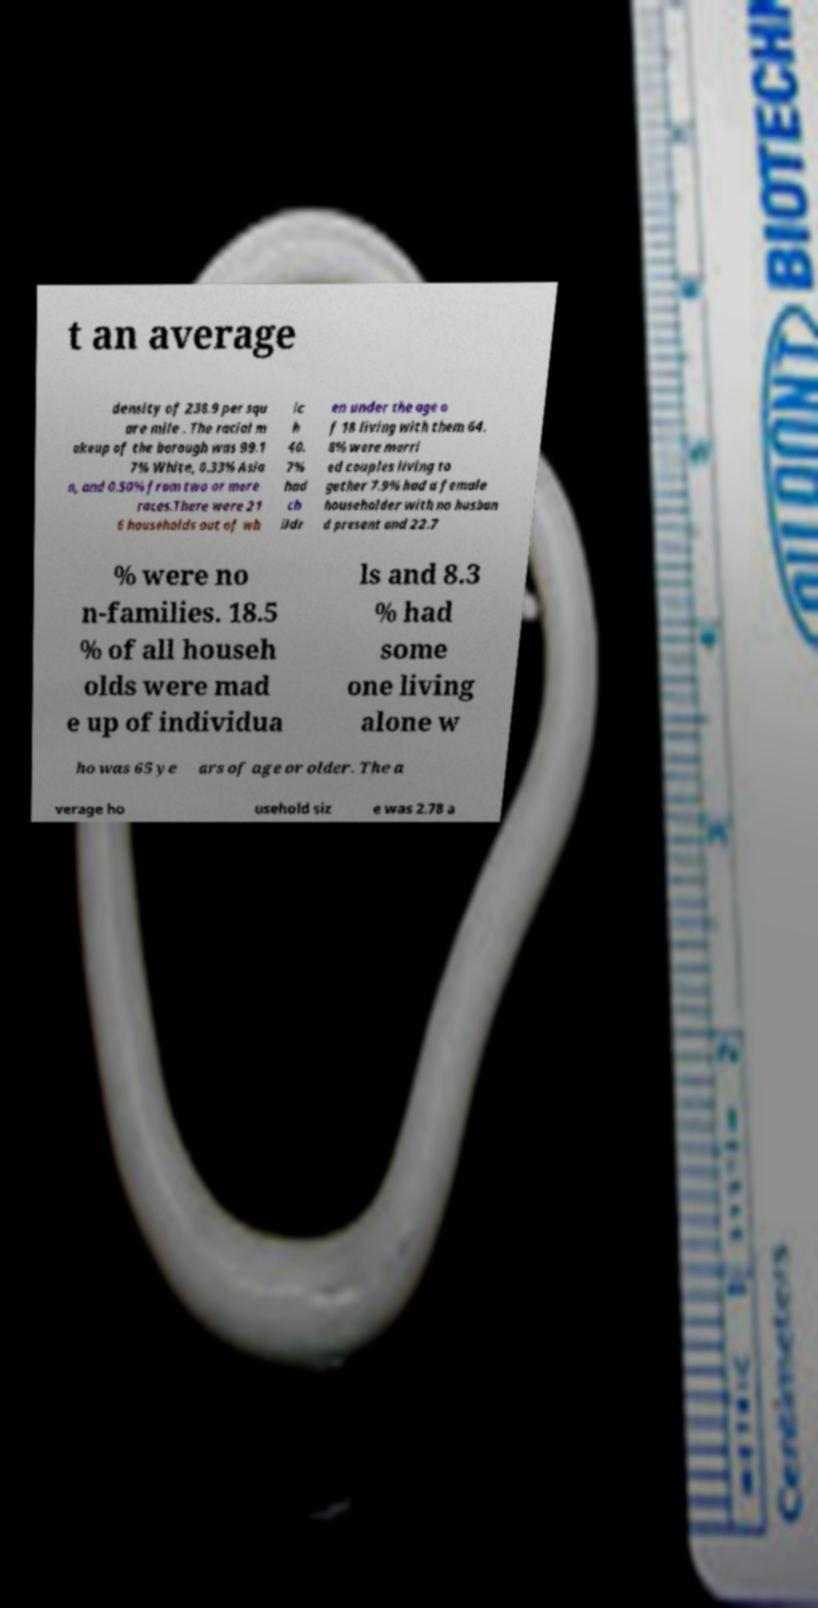Please identify and transcribe the text found in this image. t an average density of 238.9 per squ are mile . The racial m akeup of the borough was 99.1 7% White, 0.33% Asia n, and 0.50% from two or more races.There were 21 6 households out of wh ic h 40. 7% had ch ildr en under the age o f 18 living with them 64. 8% were marri ed couples living to gether 7.9% had a female householder with no husban d present and 22.7 % were no n-families. 18.5 % of all househ olds were mad e up of individua ls and 8.3 % had some one living alone w ho was 65 ye ars of age or older. The a verage ho usehold siz e was 2.78 a 